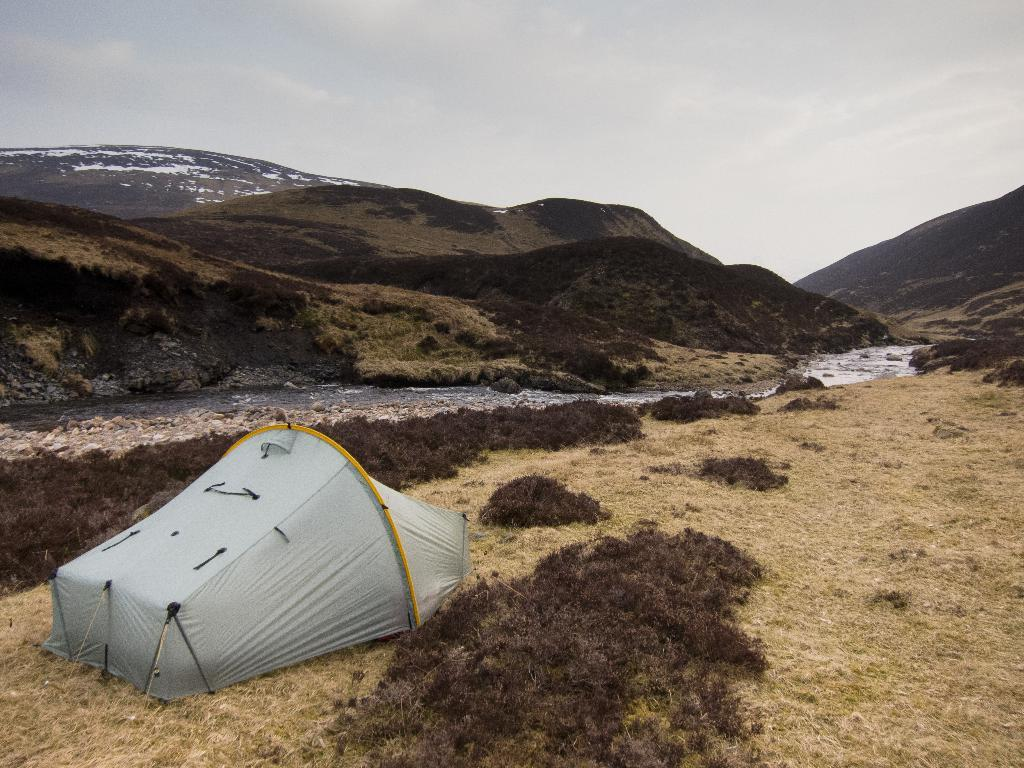What structure is placed on the ground in the image? There is a tent on the ground in the image. What natural element can be seen in the image? Water is visible in the image. What type of vegetation is present in the image? There are plants in the image. What geographical feature is visible in the image? There are mountains in the image. What is visible in the background of the image? The sky is visible in the background of the image. What can be observed in the sky? Clouds are present in the sky. What type of bubble can be seen floating near the mountains in the image? There is no bubble present in the image; it features a tent, water, plants, mountains, and a sky with clouds. How does the fuel consumption of the tent affect the environment in the image? The tent does not have fuel consumption, as it is a stationary structure. 